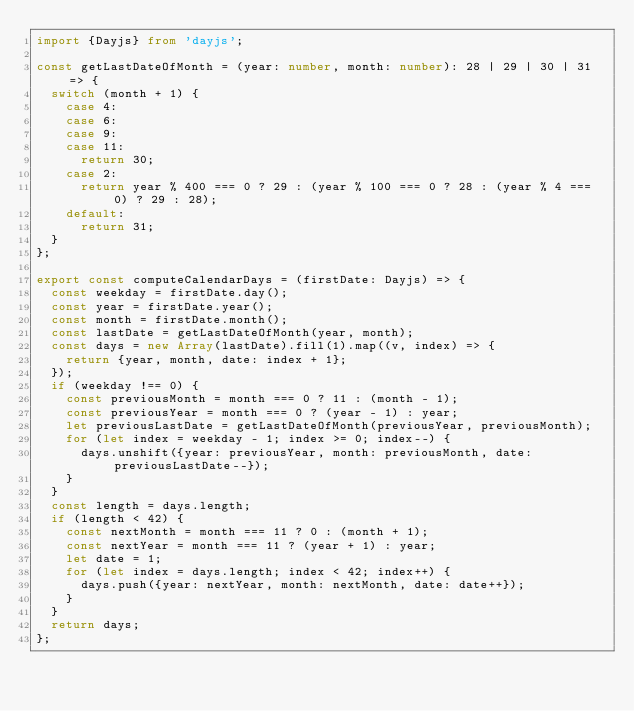<code> <loc_0><loc_0><loc_500><loc_500><_TypeScript_>import {Dayjs} from 'dayjs';

const getLastDateOfMonth = (year: number, month: number): 28 | 29 | 30 | 31 => {
	switch (month + 1) {
		case 4:
		case 6:
		case 9:
		case 11:
			return 30;
		case 2:
			return year % 400 === 0 ? 29 : (year % 100 === 0 ? 28 : (year % 4 === 0) ? 29 : 28);
		default:
			return 31;
	}
};

export const computeCalendarDays = (firstDate: Dayjs) => {
	const weekday = firstDate.day();
	const year = firstDate.year();
	const month = firstDate.month();
	const lastDate = getLastDateOfMonth(year, month);
	const days = new Array(lastDate).fill(1).map((v, index) => {
		return {year, month, date: index + 1};
	});
	if (weekday !== 0) {
		const previousMonth = month === 0 ? 11 : (month - 1);
		const previousYear = month === 0 ? (year - 1) : year;
		let previousLastDate = getLastDateOfMonth(previousYear, previousMonth);
		for (let index = weekday - 1; index >= 0; index--) {
			days.unshift({year: previousYear, month: previousMonth, date: previousLastDate--});
		}
	}
	const length = days.length;
	if (length < 42) {
		const nextMonth = month === 11 ? 0 : (month + 1);
		const nextYear = month === 11 ? (year + 1) : year;
		let date = 1;
		for (let index = days.length; index < 42; index++) {
			days.push({year: nextYear, month: nextMonth, date: date++});
		}
	}
	return days;
};
</code> 